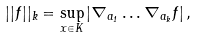<formula> <loc_0><loc_0><loc_500><loc_500>| | f | | _ { k } = \sup _ { x \in K } | \nabla _ { a _ { 1 } } \dots \nabla _ { a _ { k } } f | \, ,</formula> 